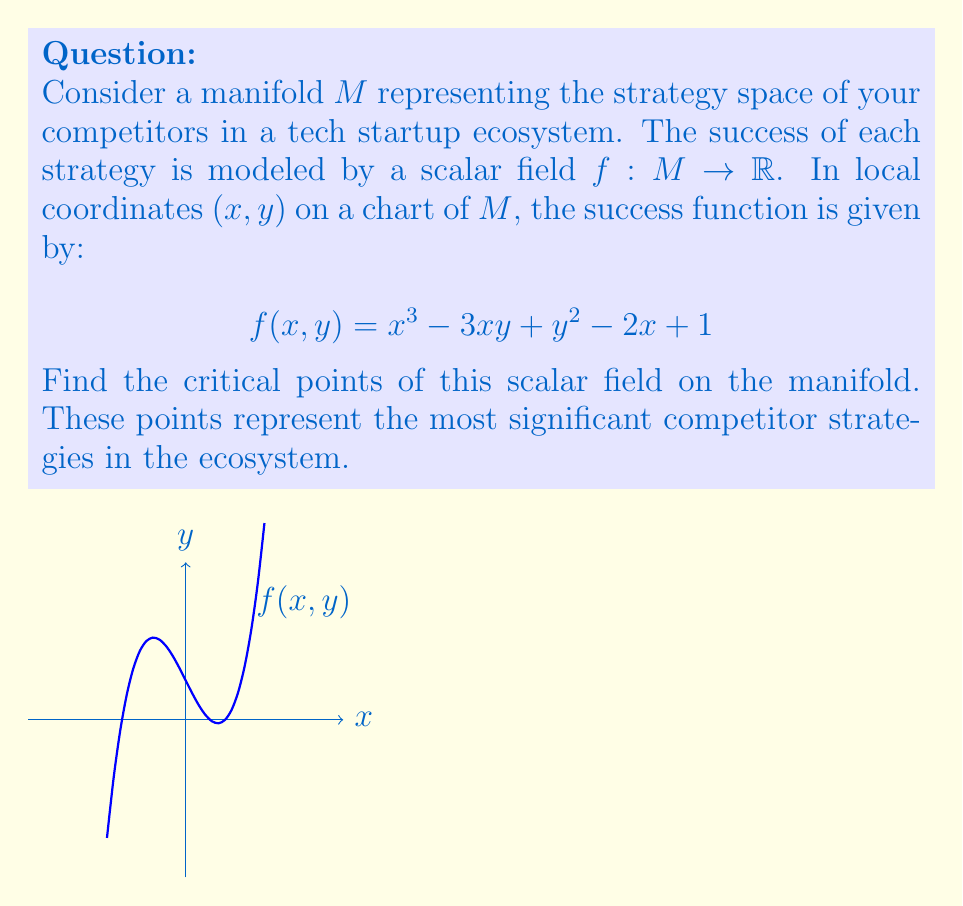Give your solution to this math problem. To find the critical points of the scalar field $f(x, y)$ on the manifold, we need to follow these steps:

1) Calculate the partial derivatives of $f$ with respect to $x$ and $y$:

   $$\frac{\partial f}{\partial x} = 3x^2 - 3y - 2$$
   $$\frac{\partial f}{\partial y} = -3x + 2y$$

2) Set both partial derivatives to zero to find the critical points:

   $$3x^2 - 3y - 2 = 0 \quad (1)$$
   $$-3x + 2y = 0 \quad (2)$$

3) From equation (2), we can express $y$ in terms of $x$:
   
   $$y = \frac{3x}{2}$$

4) Substitute this into equation (1):

   $$3x^2 - 3(\frac{3x}{2}) - 2 = 0$$
   $$3x^2 - \frac{9x}{2} - 2 = 0$$

5) Multiply all terms by 2 to eliminate fractions:

   $$6x^2 - 9x - 4 = 0$$

6) This is a quadratic equation. We can solve it using the quadratic formula:

   $$x = \frac{-b \pm \sqrt{b^2 - 4ac}}{2a}$$

   where $a = 6$, $b = -9$, and $c = -4$

7) Solving:

   $$x = \frac{9 \pm \sqrt{81 + 96}}{12} = \frac{9 \pm \sqrt{177}}{12}$$

8) This gives us two solutions for $x$:

   $$x_1 = \frac{9 + \sqrt{177}}{12} \approx 1.358$$
   $$x_2 = \frac{9 - \sqrt{177}}{12} \approx 0.142$$

9) We can find the corresponding $y$ values using $y = \frac{3x}{2}$:

   $$y_1 = \frac{3(9 + \sqrt{177})}{24} \approx 2.037$$
   $$y_2 = \frac{3(9 - \sqrt{177})}{24} \approx 0.213$$

Therefore, the critical points are approximately (1.358, 2.037) and (0.142, 0.213).
Answer: $(\frac{9 + \sqrt{177}}{12}, \frac{3(9 + \sqrt{177})}{24})$ and $(\frac{9 - \sqrt{177}}{12}, \frac{3(9 - \sqrt{177})}{24})$ 